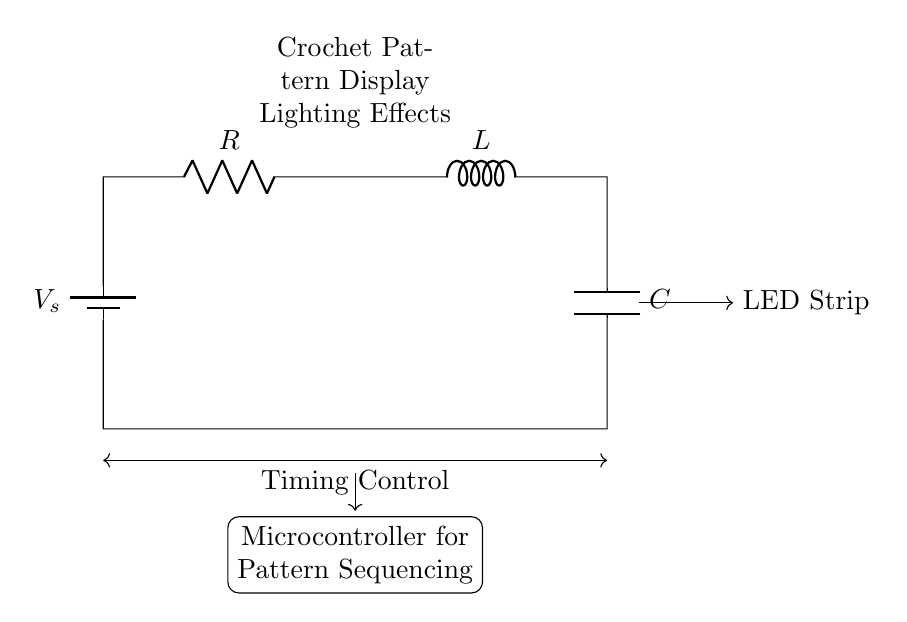What is the component labeled R? The component labeled R is a resistor, which is used to limit the current in the circuit.
Answer: Resistor What purpose does the inductor serve? The inductor, labeled L, stores energy in a magnetic field and is responsible for controlling the timing effects in this circuit.
Answer: Timing control How are the components connected in this circuit? The components R, L, and C are connected in series, which means the current flows sequentially through each component without any branching.
Answer: Series What type of circuit is this? This is a series RLC circuit, which includes a resistor, an inductor, and a capacitor, functioning together for timing effects.
Answer: Series RLC What is the function of the capacitor in this circuit? The capacitor, labeled C, stores and releases electrical energy, influencing the timing characteristics of the circuit.
Answer: Timing effect How does the microcontroller interact with the circuit? The microcontroller controls the timing and sequencing of the lighting effects by managing the energy supplied to the LED strip.
Answer: Pattern sequencing What is the role of the battery in the circuit? The battery, labeled V_s, provides the voltage necessary to drive current through the entire circuit, powering the components.
Answer: Voltage source 